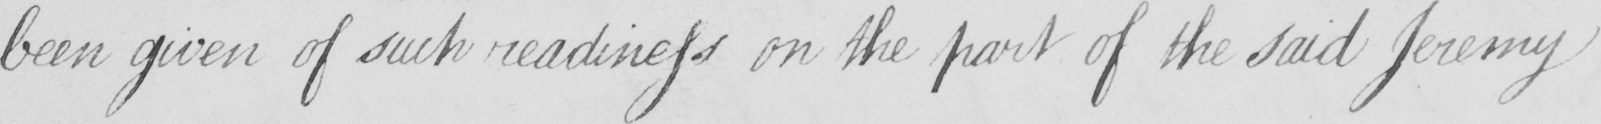What does this handwritten line say? been given of such readiness on the part of the said Jeremy 